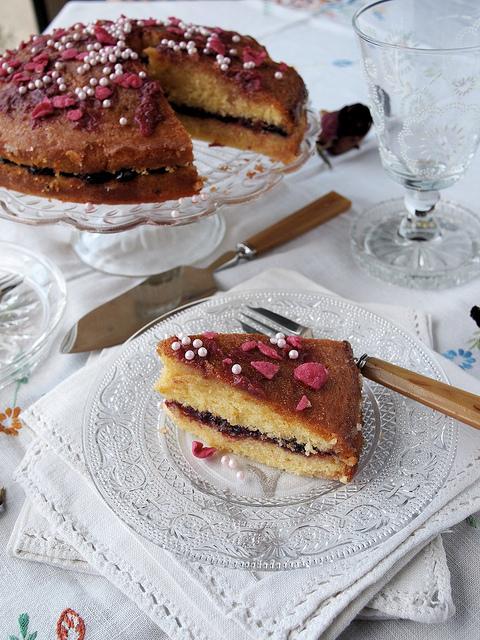Is the serving dish plastic?
Keep it brief. No. What color is the plate?
Keep it brief. Clear. How many slices of cake?
Answer briefly. 1. What dessert is in the foreground?
Give a very brief answer. Cake. How many desserts?
Give a very brief answer. 1. 